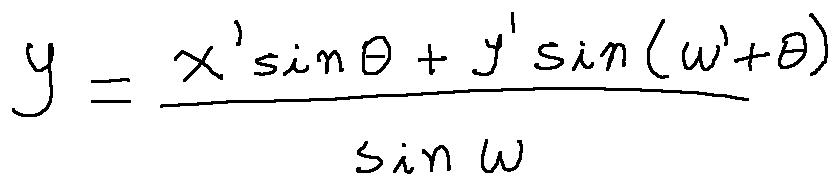Convert formula to latex. <formula><loc_0><loc_0><loc_500><loc_500>y = \frac { x \prime \sin \theta + y \prime \sin ( w \prime + \theta ) } { \sin w }</formula> 